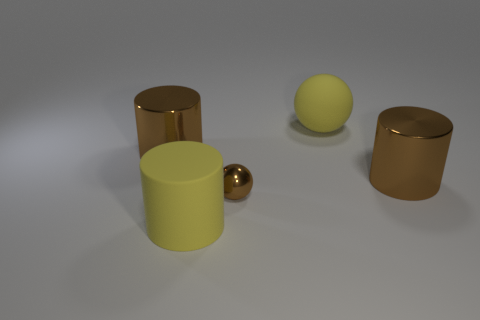Is there anything else that has the same size as the rubber sphere?
Offer a very short reply. Yes. Are there any large brown things behind the large brown thing to the left of the large yellow rubber thing in front of the small brown object?
Offer a terse response. No. There is a yellow object that is made of the same material as the yellow cylinder; what is its shape?
Provide a short and direct response. Sphere. Is there anything else that is the same shape as the small brown object?
Make the answer very short. Yes. Does the big yellow thing to the right of the big matte cylinder have the same shape as the tiny metallic thing?
Offer a very short reply. Yes. Are there more large brown cylinders behind the yellow matte ball than small brown things that are left of the tiny brown metallic ball?
Provide a short and direct response. No. What number of other things are the same size as the brown metallic sphere?
Provide a short and direct response. 0. Does the small shiny object have the same shape as the large metal object that is to the right of the big yellow cylinder?
Your response must be concise. No. How many shiny objects are spheres or brown things?
Your response must be concise. 3. Is there a metal object that has the same color as the large sphere?
Your response must be concise. No. 